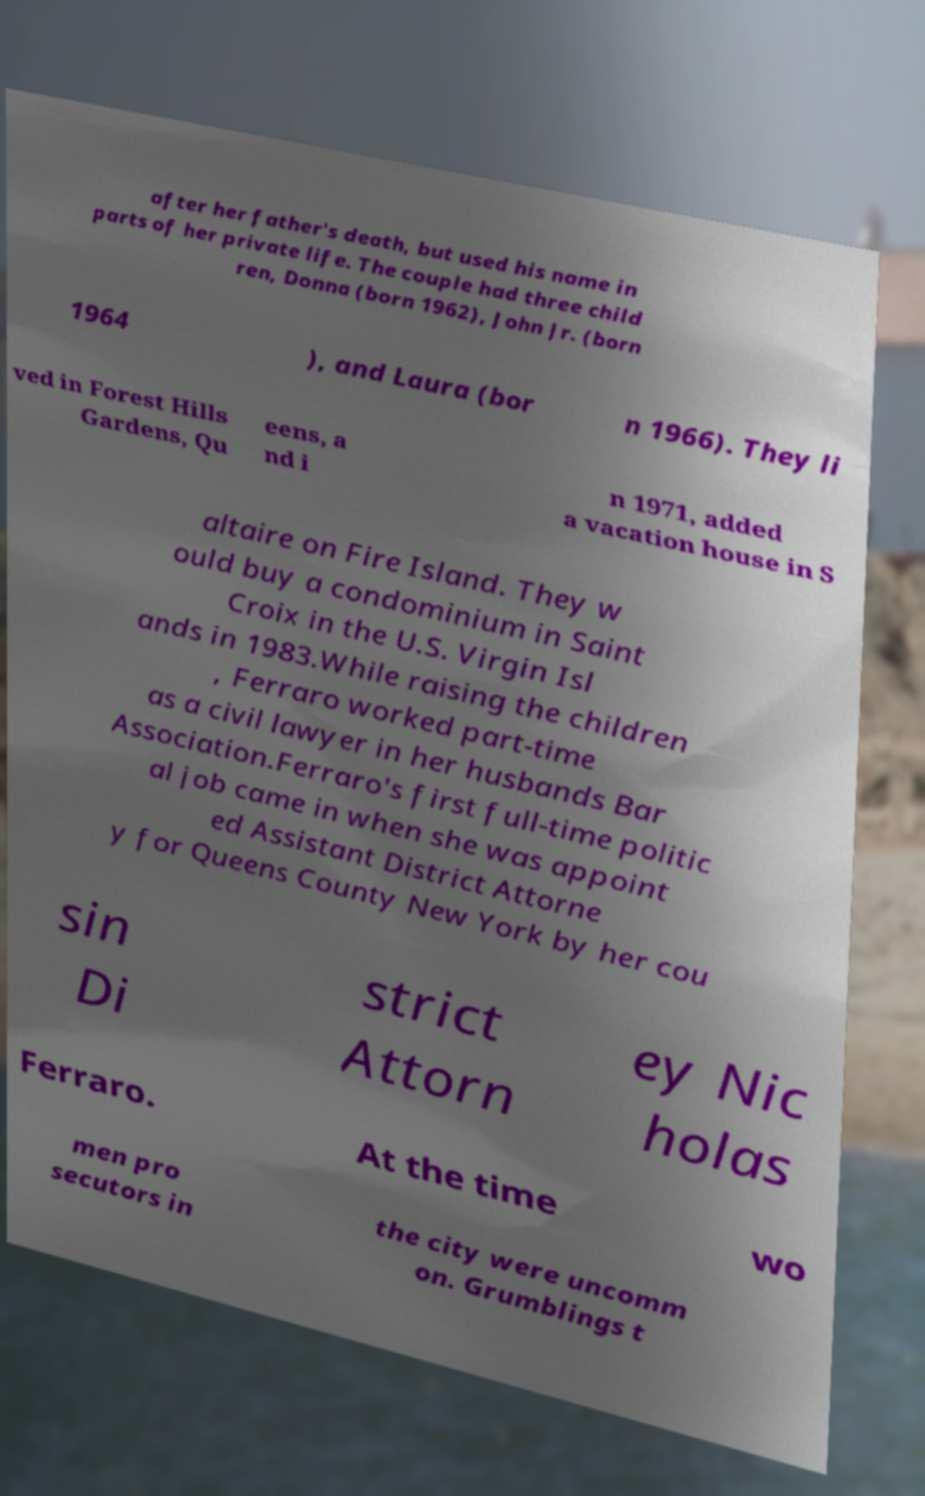There's text embedded in this image that I need extracted. Can you transcribe it verbatim? after her father's death, but used his name in parts of her private life. The couple had three child ren, Donna (born 1962), John Jr. (born 1964 ), and Laura (bor n 1966). They li ved in Forest Hills Gardens, Qu eens, a nd i n 1971, added a vacation house in S altaire on Fire Island. They w ould buy a condominium in Saint Croix in the U.S. Virgin Isl ands in 1983.While raising the children , Ferraro worked part-time as a civil lawyer in her husbands Bar Association.Ferraro's first full-time politic al job came in when she was appoint ed Assistant District Attorne y for Queens County New York by her cou sin Di strict Attorn ey Nic holas Ferraro. At the time wo men pro secutors in the city were uncomm on. Grumblings t 